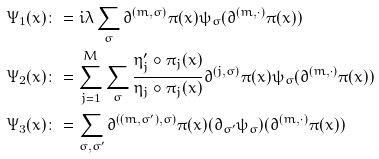<formula> <loc_0><loc_0><loc_500><loc_500>\Psi _ { 1 } ( x ) & \colon = i \lambda \sum _ { \sigma } \partial ^ { ( m , \sigma ) } \pi ( x ) \psi _ { \sigma } ( \partial ^ { ( m , \cdot ) } \pi ( x ) ) \\ \Psi _ { 2 } ( x ) & \colon = \sum _ { j = 1 } ^ { M } \sum _ { \sigma } \frac { \eta _ { j } ^ { \prime } \circ \pi _ { j } ( x ) } { \eta _ { j } \circ \pi _ { j } ( x ) } \partial ^ { ( j , \sigma ) } \pi ( x ) \psi _ { \sigma } ( \partial ^ { ( m , \cdot ) } \pi ( x ) ) \\ \Psi _ { 3 } ( x ) & \colon = \sum _ { \sigma , \sigma ^ { \prime } } \partial ^ { ( ( m , \sigma ^ { \prime } ) , \sigma ) } \pi ( x ) ( \partial _ { \sigma ^ { \prime } } \psi _ { \sigma } ) ( \partial ^ { ( m , \cdot ) } \pi ( x ) )</formula> 